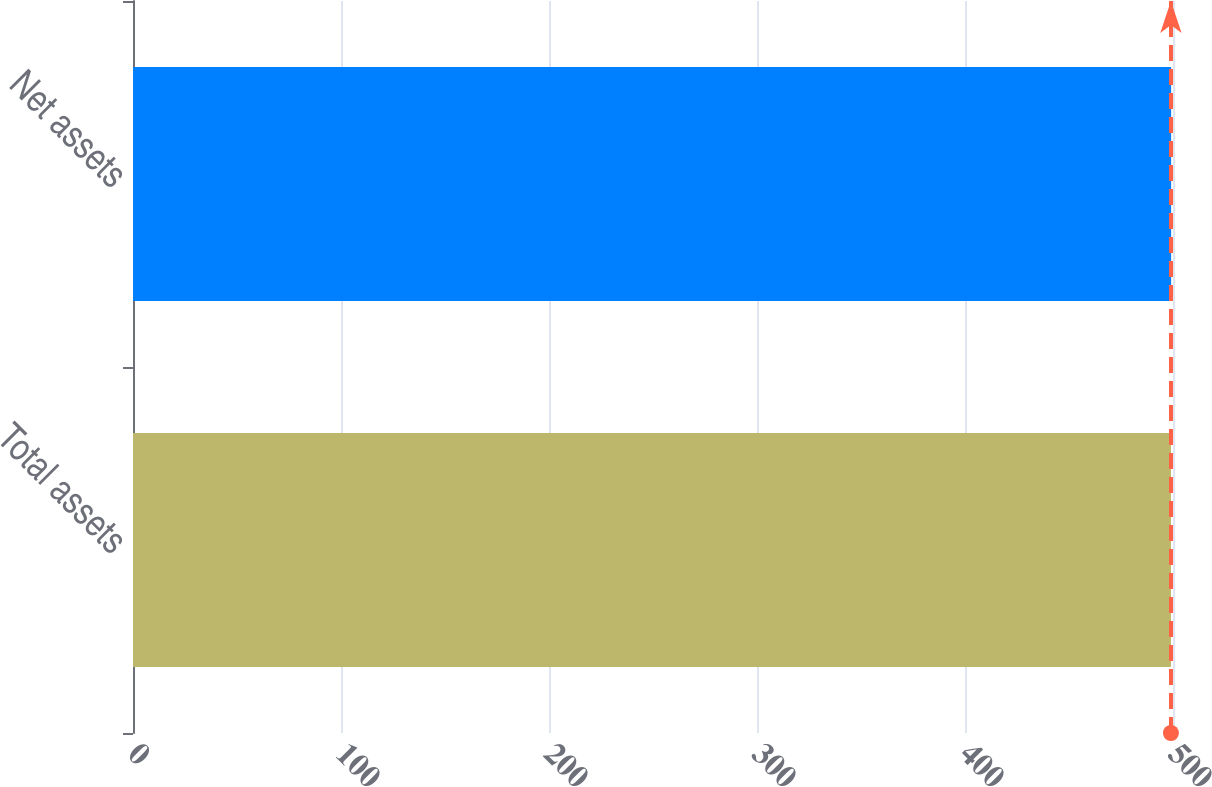<chart> <loc_0><loc_0><loc_500><loc_500><bar_chart><fcel>Total assets<fcel>Net assets<nl><fcel>499<fcel>499.1<nl></chart> 